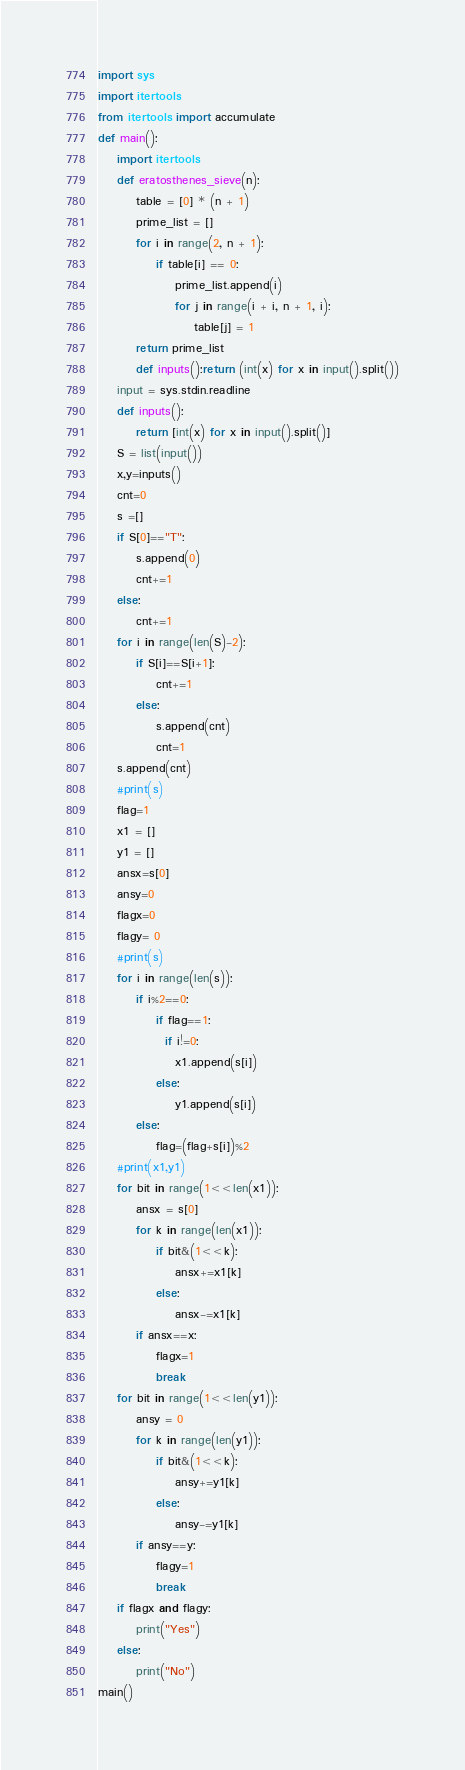<code> <loc_0><loc_0><loc_500><loc_500><_Python_>import sys
import itertools
from itertools import accumulate
def main():
    import itertools
    def eratosthenes_sieve(n):
        table = [0] * (n + 1)
        prime_list = []
        for i in range(2, n + 1):
            if table[i] == 0:
                prime_list.append(i)
                for j in range(i + i, n + 1, i):
                    table[j] = 1
        return prime_list
        def inputs():return (int(x) for x in input().split())
    input = sys.stdin.readline
    def inputs():
        return [int(x) for x in input().split()]
    S = list(input())
    x,y=inputs()
    cnt=0
    s =[]
    if S[0]=="T":
        s.append(0)
        cnt+=1
    else:
        cnt+=1
    for i in range(len(S)-2):
        if S[i]==S[i+1]:
            cnt+=1
        else:
            s.append(cnt)
            cnt=1
    s.append(cnt)
    #print(s)
    flag=1
    x1 = []
    y1 = []
    ansx=s[0]
    ansy=0
    flagx=0
    flagy= 0
    #print(s)
    for i in range(len(s)):
        if i%2==0:
            if flag==1:
              if i!=0:
                x1.append(s[i])
            else:
                y1.append(s[i])
        else:
            flag=(flag+s[i])%2
    #print(x1,y1)
    for bit in range(1<<len(x1)):
        ansx = s[0]
        for k in range(len(x1)):
            if bit&(1<<k):
                ansx+=x1[k]
            else:
                ansx-=x1[k]
        if ansx==x:
            flagx=1
            break
    for bit in range(1<<len(y1)):
        ansy = 0
        for k in range(len(y1)):
            if bit&(1<<k):
                ansy+=y1[k]
            else:
                ansy-=y1[k]
        if ansy==y:
            flagy=1
            break
    if flagx and flagy:
        print("Yes")
    else:
        print("No")
main()</code> 